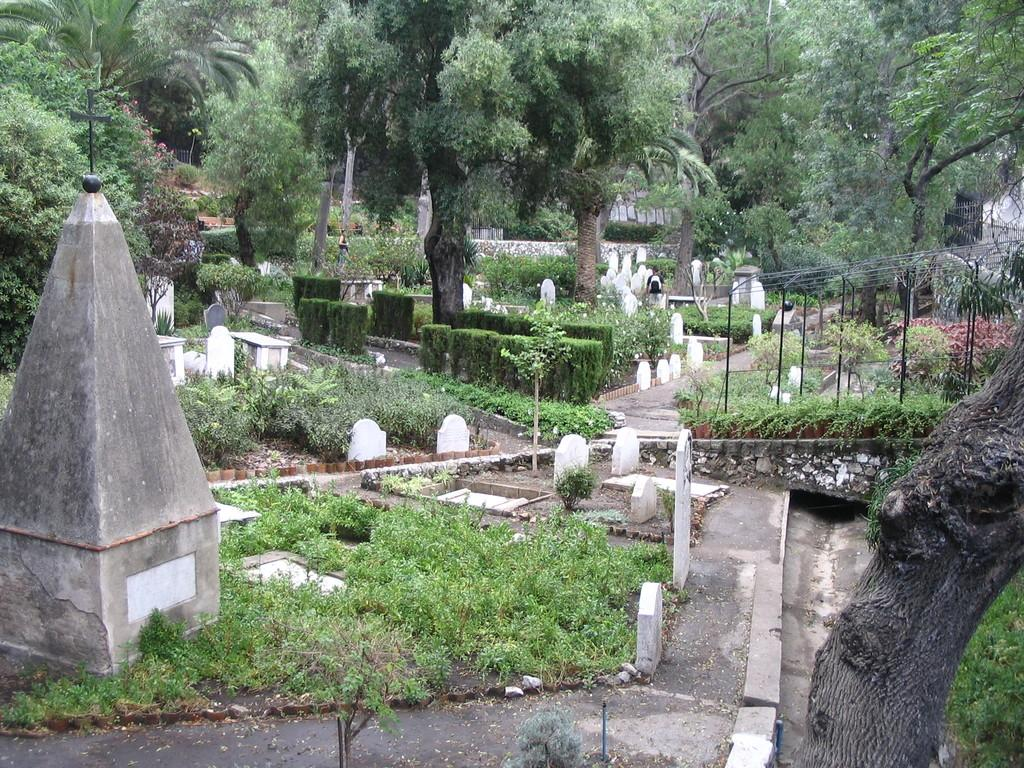What type of structures can be seen in the image? There are graveyard stones and a concrete structure on the left side of the image. What type of vegetation is present in the image? There is grass, plants, and trees in the image. What type of poles can be seen in the image? There are black color poles in the image. Is there a path in the image? Yes, there is a path in the image. What type of produce is being harvested in the image? There is no produce being harvested in the image; it features a graveyard with stones, plants, trees, and a path. What language is spoken by the people in the image? There are no people present in the image, so it is not possible to determine the language spoken. 